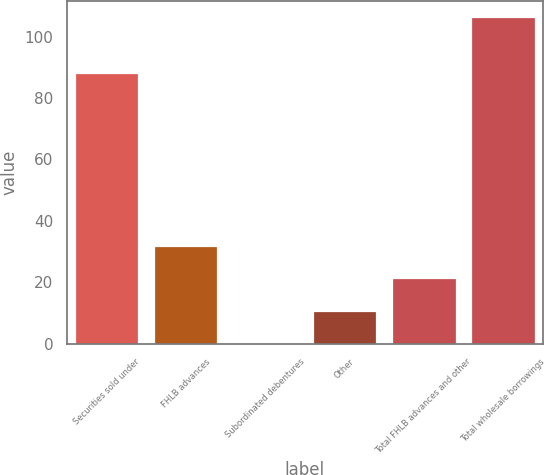<chart> <loc_0><loc_0><loc_500><loc_500><bar_chart><fcel>Securities sold under<fcel>FHLB advances<fcel>Subordinated debentures<fcel>Other<fcel>Total FHLB advances and other<fcel>Total wholesale borrowings<nl><fcel>88.1<fcel>31.96<fcel>0.1<fcel>10.72<fcel>21.34<fcel>106.3<nl></chart> 